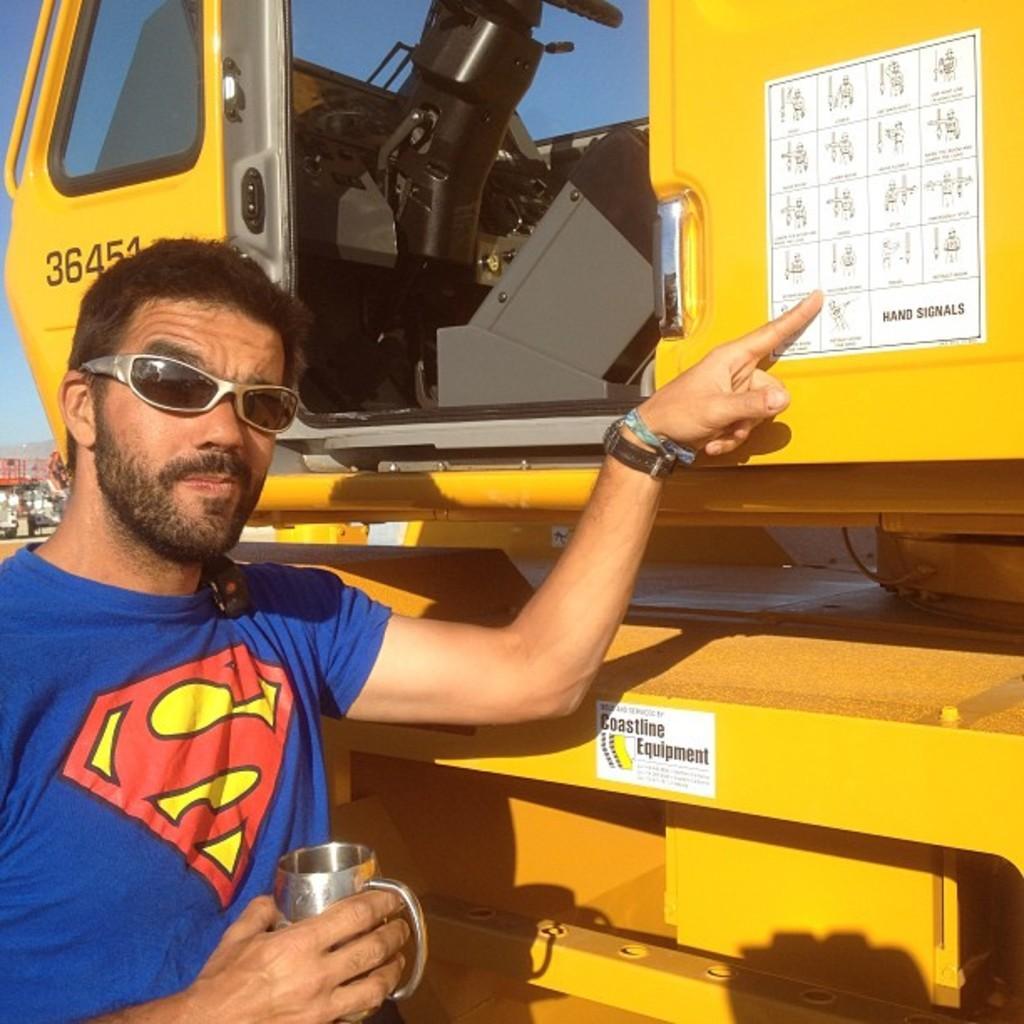Describe this image in one or two sentences. In this image, we can see a person is holding a cup and wearing goggles. Here we can see a vehicle. On that we can see some posters. Background there is a sky. 